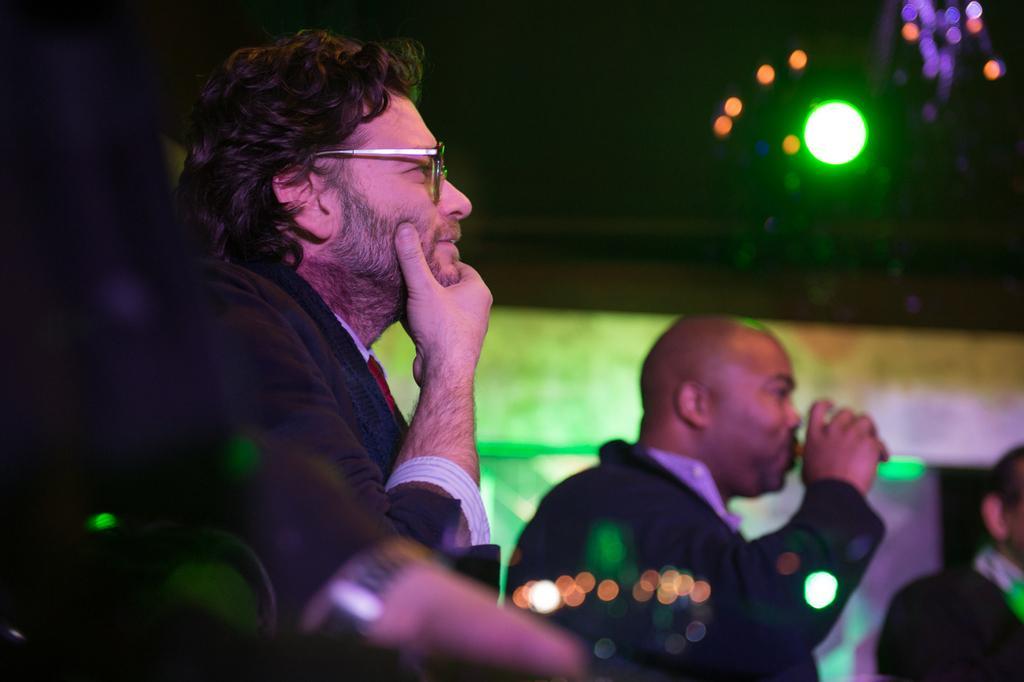In one or two sentences, can you explain what this image depicts? In the I can see a man on the left side. I can see another man and he is holding a glass in his right hand. There is another person on the bottom right side though his face is not visible. There is a decorative lamp on the top right side. 